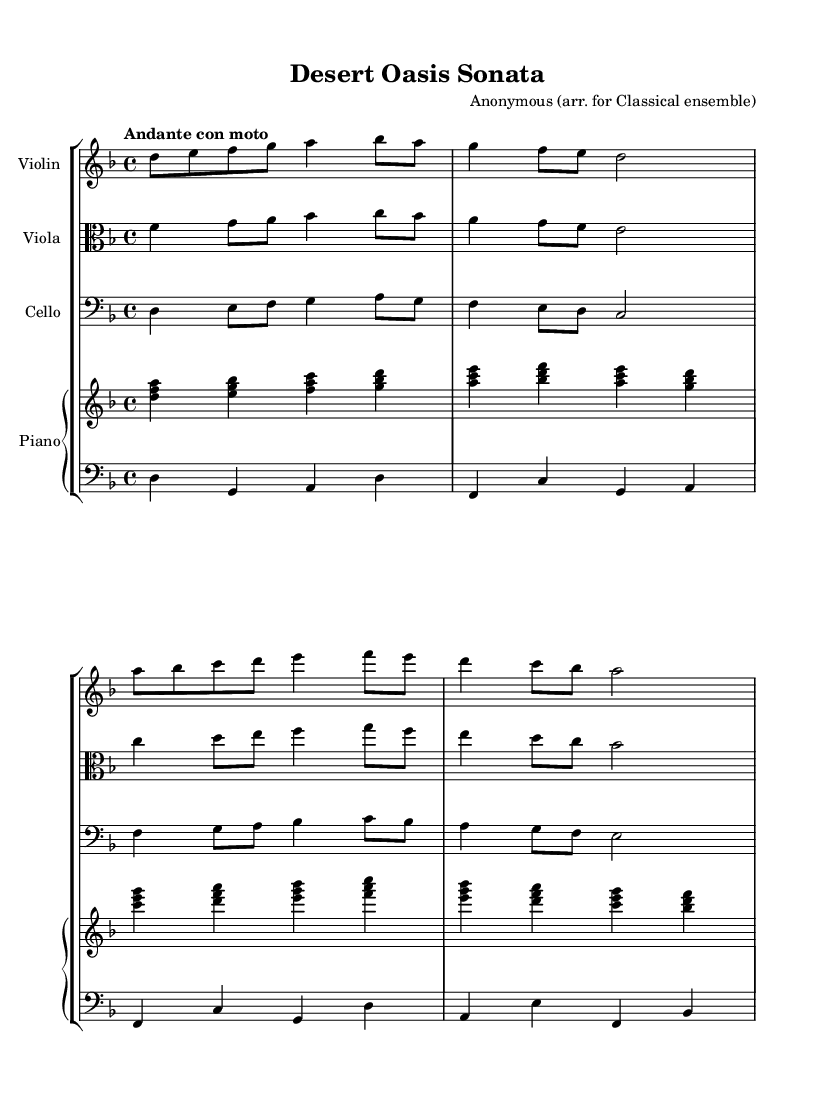What is the key signature of this music? The key signature is D minor, which has one flat (C).
Answer: D minor What is the time signature of the piece? The time signature is 4/4, indicating four beats per measure.
Answer: 4/4 What is the tempo marking? The tempo marking is "Andante con moto," indicating a moderately slow tempo with some movement.
Answer: Andante con moto Which instruments are in the ensemble? The ensemble consists of violin, viola, cello, and piano.
Answer: Violin, viola, cello, piano How many measures does the first violin part have? The first violin part has a total of 8 measures.
Answer: 8 measures What is the range of the cello part? The cello part spans from D in the bass clef to A in the tenor clef, suggesting a range of about two octaves.
Answer: Two octaves How does the piano left hand contribute rhythmically to the piece? The piano left hand provides a rhythmic foundation with sustained notes on the downbeats, complementing the harmonic structure.
Answer: Rhythmic foundation 